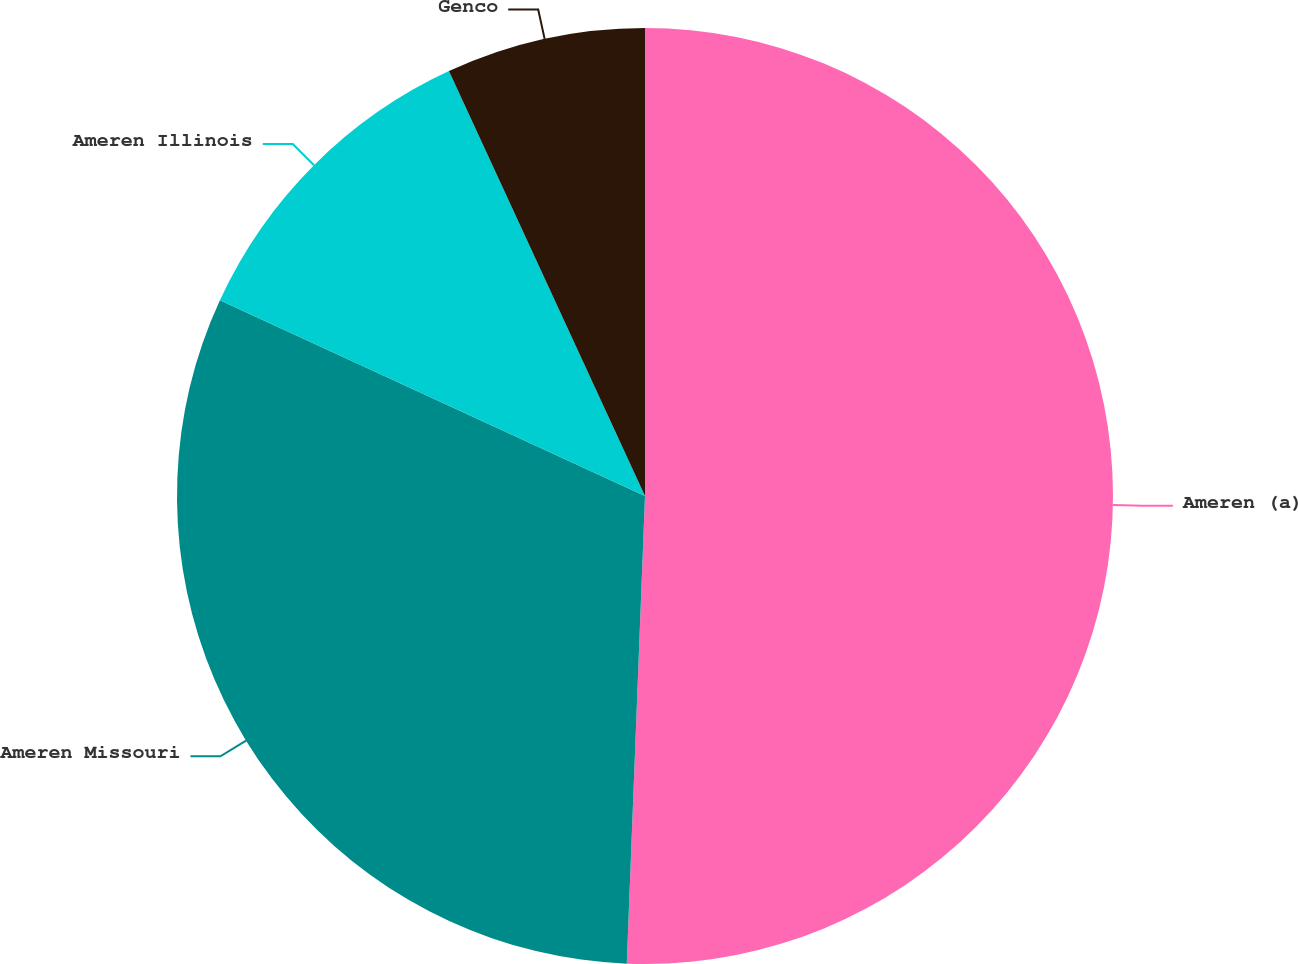<chart> <loc_0><loc_0><loc_500><loc_500><pie_chart><fcel>Ameren (a)<fcel>Ameren Missouri<fcel>Ameren Illinois<fcel>Genco<nl><fcel>50.62%<fcel>31.25%<fcel>11.25%<fcel>6.88%<nl></chart> 